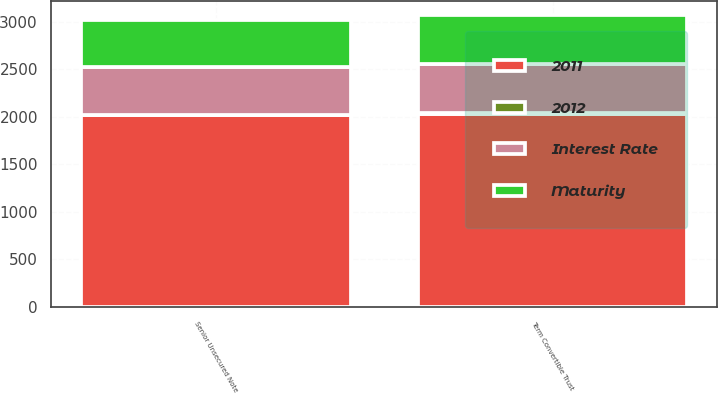Convert chart to OTSL. <chart><loc_0><loc_0><loc_500><loc_500><stacked_bar_chart><ecel><fcel>Senior Unsecured Note<fcel>Term Convertible Trust<nl><fcel>2012<fcel>7.75<fcel>6.75<nl><fcel>2011<fcel>2014<fcel>2029<nl><fcel>Maturity<fcel>500<fcel>517<nl><fcel>Interest Rate<fcel>500<fcel>517<nl></chart> 